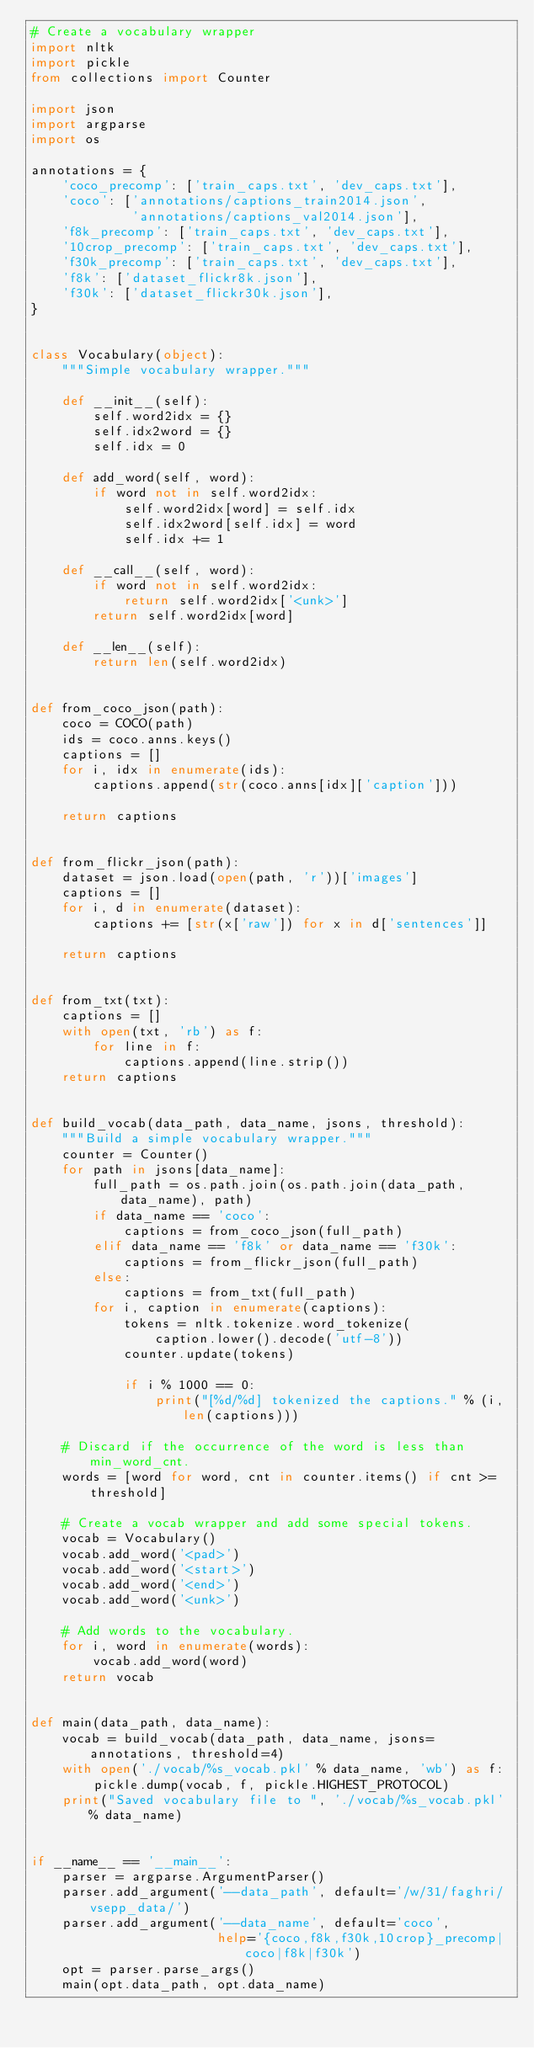Convert code to text. <code><loc_0><loc_0><loc_500><loc_500><_Python_># Create a vocabulary wrapper
import nltk
import pickle
from collections import Counter

import json
import argparse
import os

annotations = {
    'coco_precomp': ['train_caps.txt', 'dev_caps.txt'],
    'coco': ['annotations/captions_train2014.json',
             'annotations/captions_val2014.json'],
    'f8k_precomp': ['train_caps.txt', 'dev_caps.txt'],
    '10crop_precomp': ['train_caps.txt', 'dev_caps.txt'],
    'f30k_precomp': ['train_caps.txt', 'dev_caps.txt'],
    'f8k': ['dataset_flickr8k.json'],
    'f30k': ['dataset_flickr30k.json'],
}


class Vocabulary(object):
    """Simple vocabulary wrapper."""

    def __init__(self):
        self.word2idx = {}
        self.idx2word = {}
        self.idx = 0

    def add_word(self, word):
        if word not in self.word2idx:
            self.word2idx[word] = self.idx
            self.idx2word[self.idx] = word
            self.idx += 1

    def __call__(self, word):
        if word not in self.word2idx:
            return self.word2idx['<unk>']
        return self.word2idx[word]

    def __len__(self):
        return len(self.word2idx)


def from_coco_json(path):
    coco = COCO(path)
    ids = coco.anns.keys()
    captions = []
    for i, idx in enumerate(ids):
        captions.append(str(coco.anns[idx]['caption']))

    return captions


def from_flickr_json(path):
    dataset = json.load(open(path, 'r'))['images']
    captions = []
    for i, d in enumerate(dataset):
        captions += [str(x['raw']) for x in d['sentences']]

    return captions


def from_txt(txt):
    captions = []
    with open(txt, 'rb') as f:
        for line in f:
            captions.append(line.strip())
    return captions


def build_vocab(data_path, data_name, jsons, threshold):
    """Build a simple vocabulary wrapper."""
    counter = Counter()
    for path in jsons[data_name]:
        full_path = os.path.join(os.path.join(data_path, data_name), path)
        if data_name == 'coco':
            captions = from_coco_json(full_path)
        elif data_name == 'f8k' or data_name == 'f30k':
            captions = from_flickr_json(full_path)
        else:
            captions = from_txt(full_path)
        for i, caption in enumerate(captions):
            tokens = nltk.tokenize.word_tokenize(
                caption.lower().decode('utf-8'))
            counter.update(tokens)

            if i % 1000 == 0:
                print("[%d/%d] tokenized the captions." % (i, len(captions)))

    # Discard if the occurrence of the word is less than min_word_cnt.
    words = [word for word, cnt in counter.items() if cnt >= threshold]

    # Create a vocab wrapper and add some special tokens.
    vocab = Vocabulary()
    vocab.add_word('<pad>')
    vocab.add_word('<start>')
    vocab.add_word('<end>')
    vocab.add_word('<unk>')

    # Add words to the vocabulary.
    for i, word in enumerate(words):
        vocab.add_word(word)
    return vocab


def main(data_path, data_name):
    vocab = build_vocab(data_path, data_name, jsons=annotations, threshold=4)
    with open('./vocab/%s_vocab.pkl' % data_name, 'wb') as f:
        pickle.dump(vocab, f, pickle.HIGHEST_PROTOCOL)
    print("Saved vocabulary file to ", './vocab/%s_vocab.pkl' % data_name)


if __name__ == '__main__':
    parser = argparse.ArgumentParser()
    parser.add_argument('--data_path', default='/w/31/faghri/vsepp_data/')
    parser.add_argument('--data_name', default='coco',
                        help='{coco,f8k,f30k,10crop}_precomp|coco|f8k|f30k')
    opt = parser.parse_args()
    main(opt.data_path, opt.data_name)
</code> 